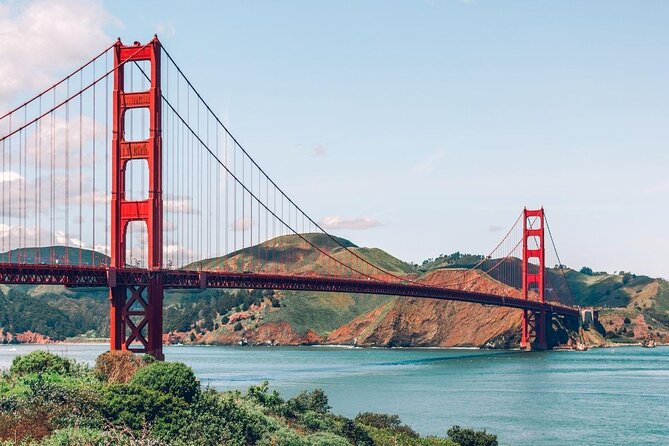This view is so serene. Can you describe a day in the life of someone who works on maintaining the bridge? A day in the life of a maintenance worker on the Golden Gate Bridge is both demanding and exhilarating. Imagine starting the day early, equipped with safety gear, ready to check and repair any wear and tear. The morning begins with a meeting to assign tasks, whether it's inspecting cables, painting over rust spots, or ensuring the structural integrity of the bridge. Working hundreds of feet above water, they brave fierce winds, fog, and sometimes even thrill-seeking tourists. Despite the physical challenge, there's an unparalleled sense of pride and accomplishment in preserving this iconic structure for future generations. Sounds intense! What do you think they feel when they see the bridge they help maintain by nightfall? By nightfall, as the city lights twinkle and the bridge glows under the evening sky, maintenance workers likely feel a profound sense of fulfillment. Looking at the bridge illuminated against the backdrop of the city, they might reflect on the crucial role they play in its upkeep, the unseen protector of this landmark. Pride, joy, and a deep connection to both the bridge and the community it serves are feelings that probably resonate with them, knowing that their efforts allow the bridge to remain a safe and beautiful symbol of the city. 